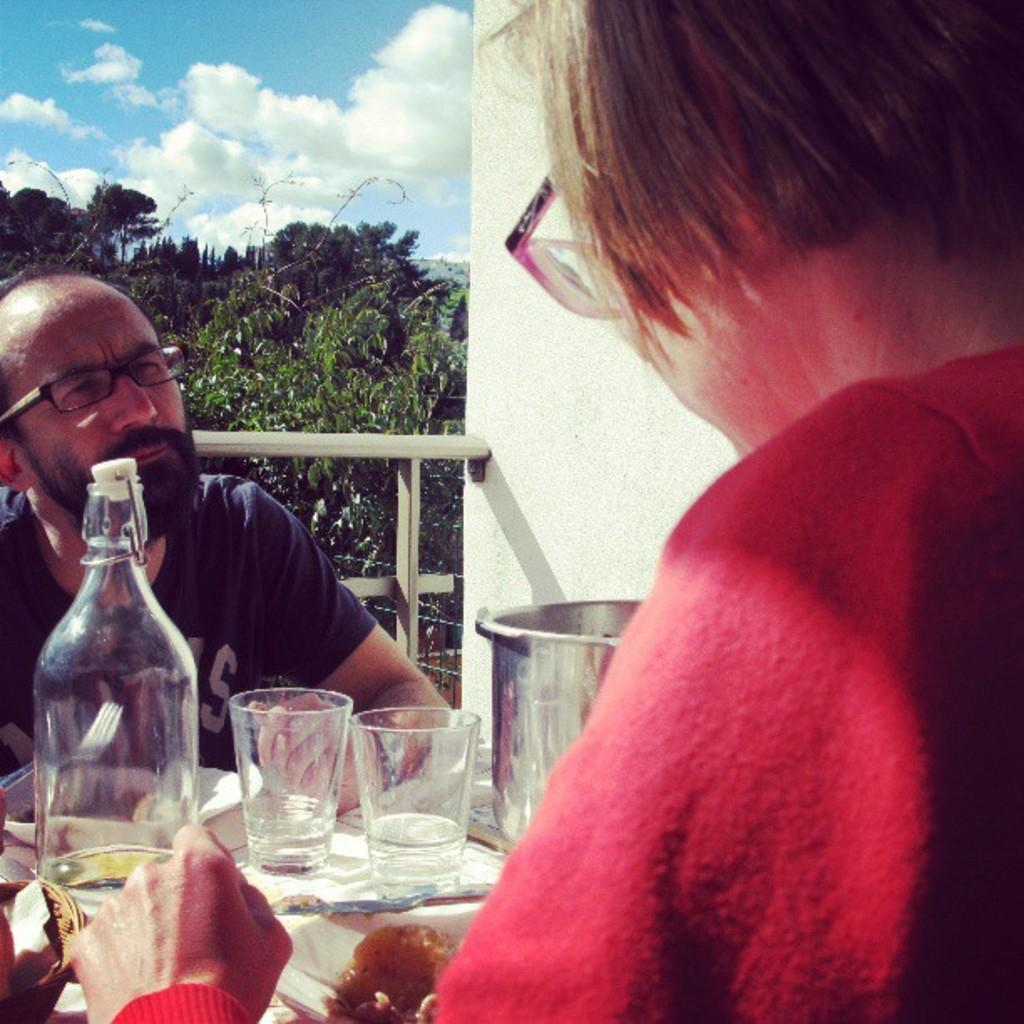How many people are present in the image? There are two people in the image, a man and a woman. What are the man and woman doing in the image? Both the man and woman are sitting in front of a table. What can be seen on the table in the image? There are two water glasses, a water bottle, and food in a plate on the table. What is the man's focus in the image? The man is staring at the woman. What type of toy is the man playing with in the image? There is no toy present in the image; the man is sitting and staring at the woman. 